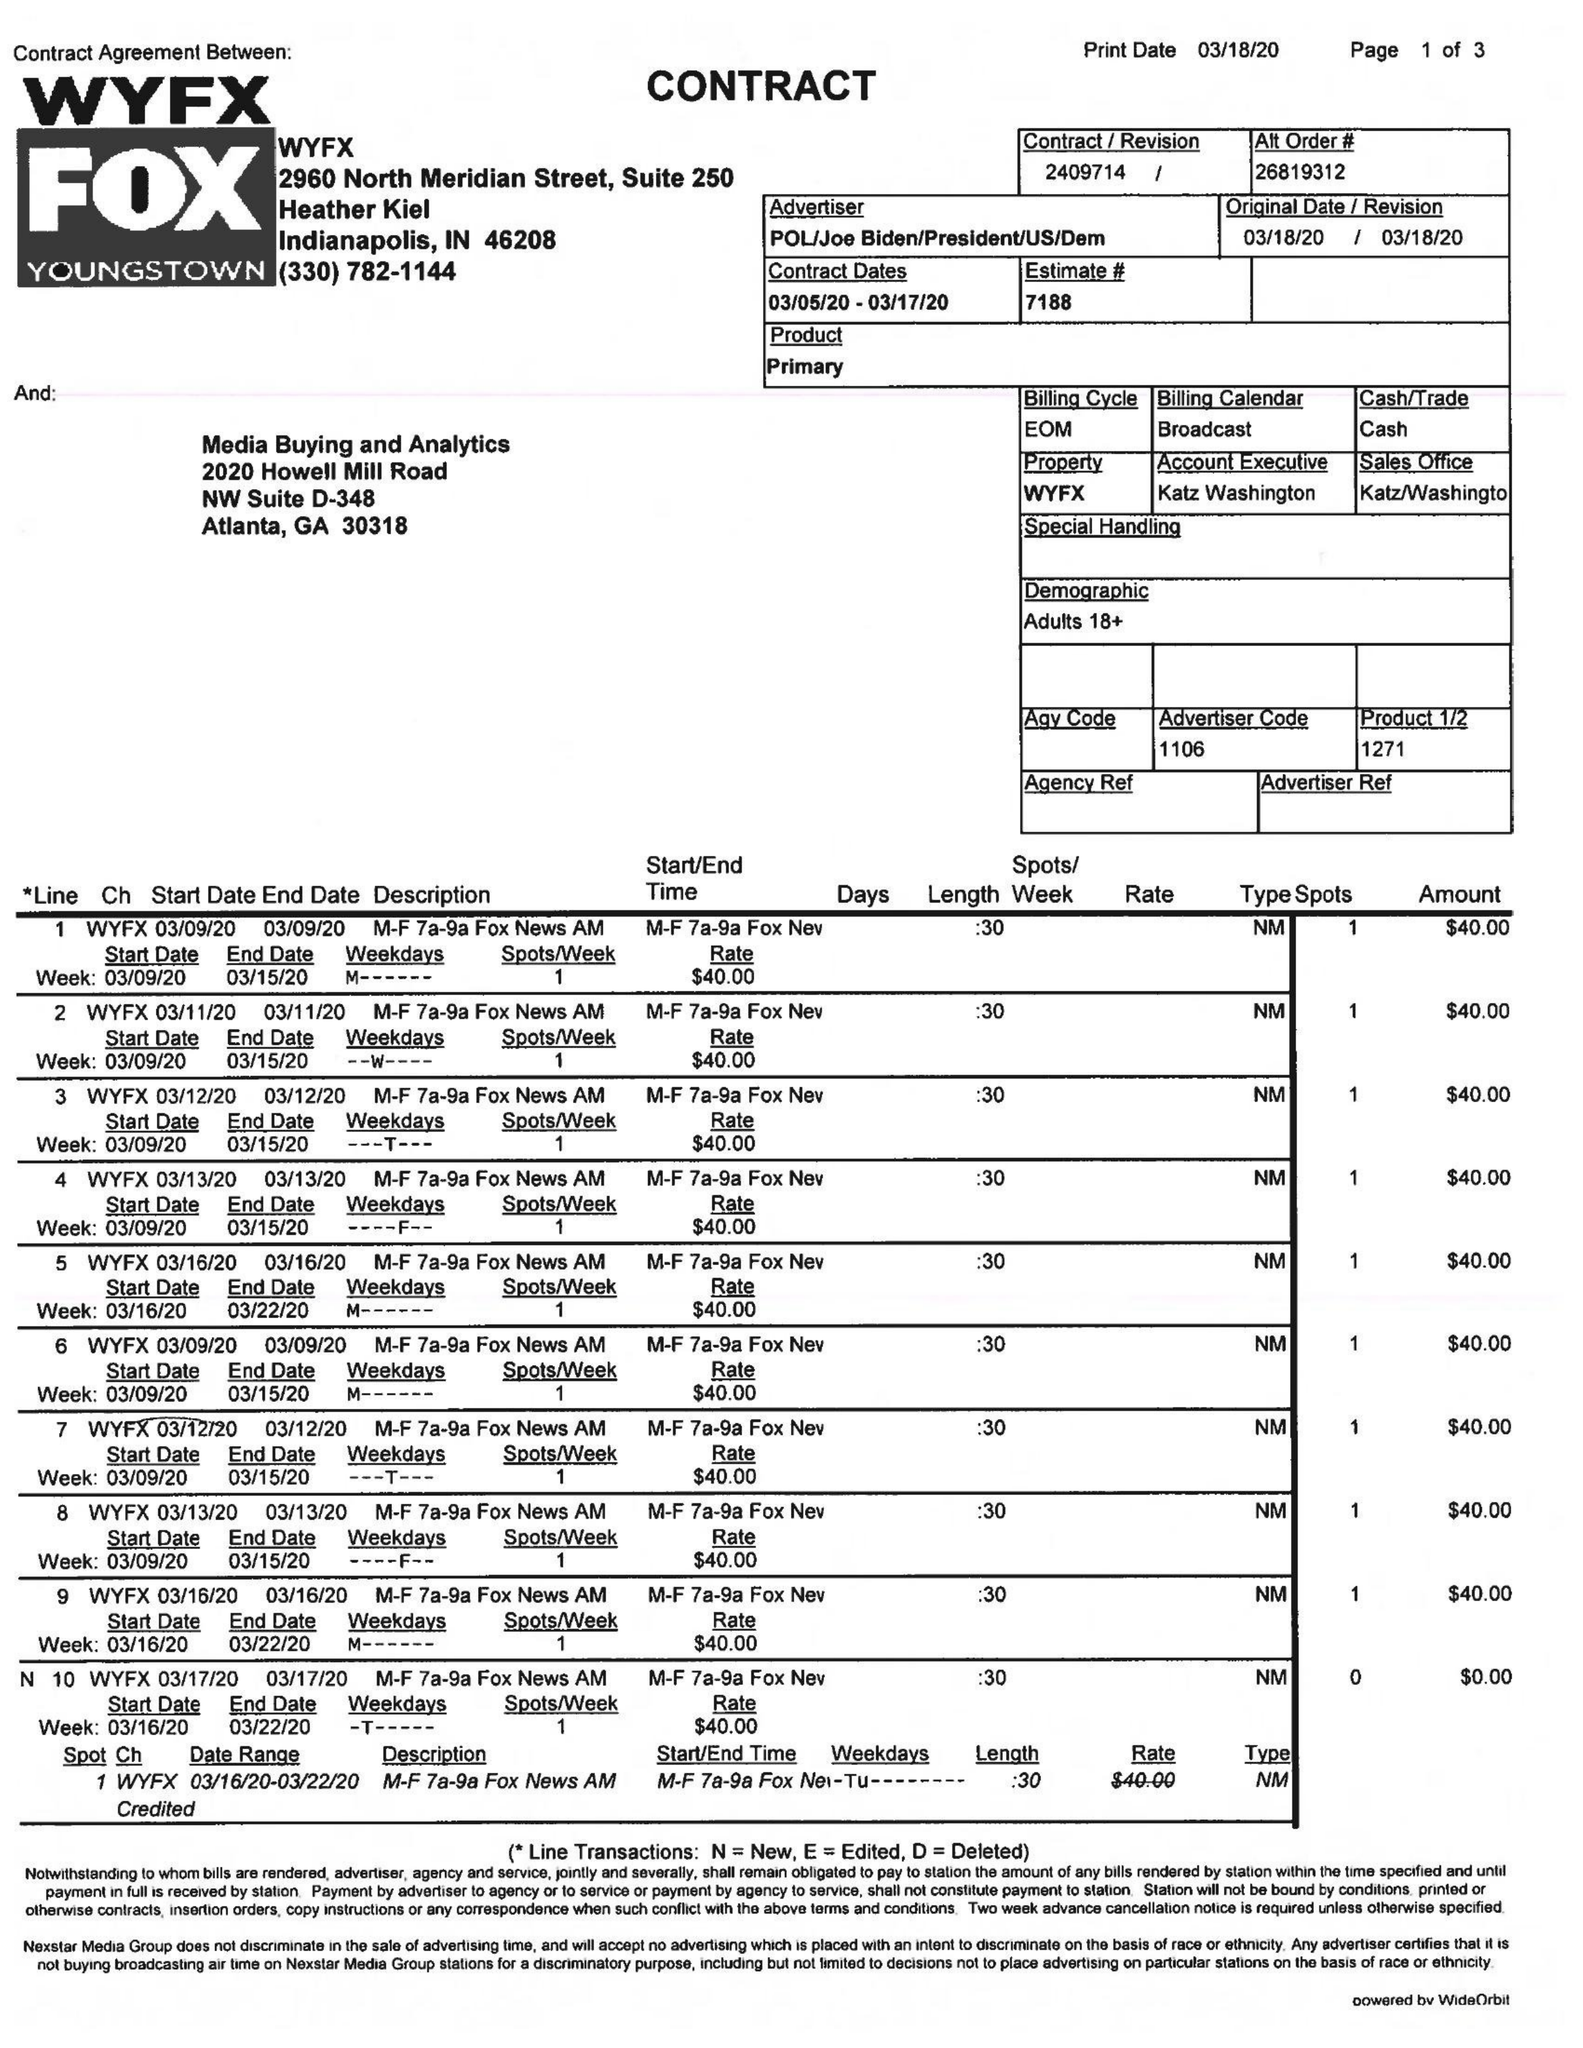What is the value for the flight_to?
Answer the question using a single word or phrase. 03/17/20 